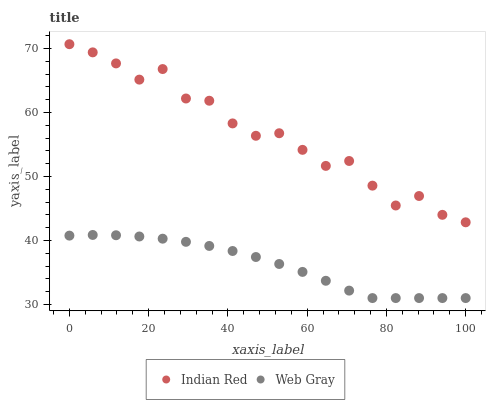Does Web Gray have the minimum area under the curve?
Answer yes or no. Yes. Does Indian Red have the maximum area under the curve?
Answer yes or no. Yes. Does Indian Red have the minimum area under the curve?
Answer yes or no. No. Is Web Gray the smoothest?
Answer yes or no. Yes. Is Indian Red the roughest?
Answer yes or no. Yes. Is Indian Red the smoothest?
Answer yes or no. No. Does Web Gray have the lowest value?
Answer yes or no. Yes. Does Indian Red have the lowest value?
Answer yes or no. No. Does Indian Red have the highest value?
Answer yes or no. Yes. Is Web Gray less than Indian Red?
Answer yes or no. Yes. Is Indian Red greater than Web Gray?
Answer yes or no. Yes. Does Web Gray intersect Indian Red?
Answer yes or no. No. 